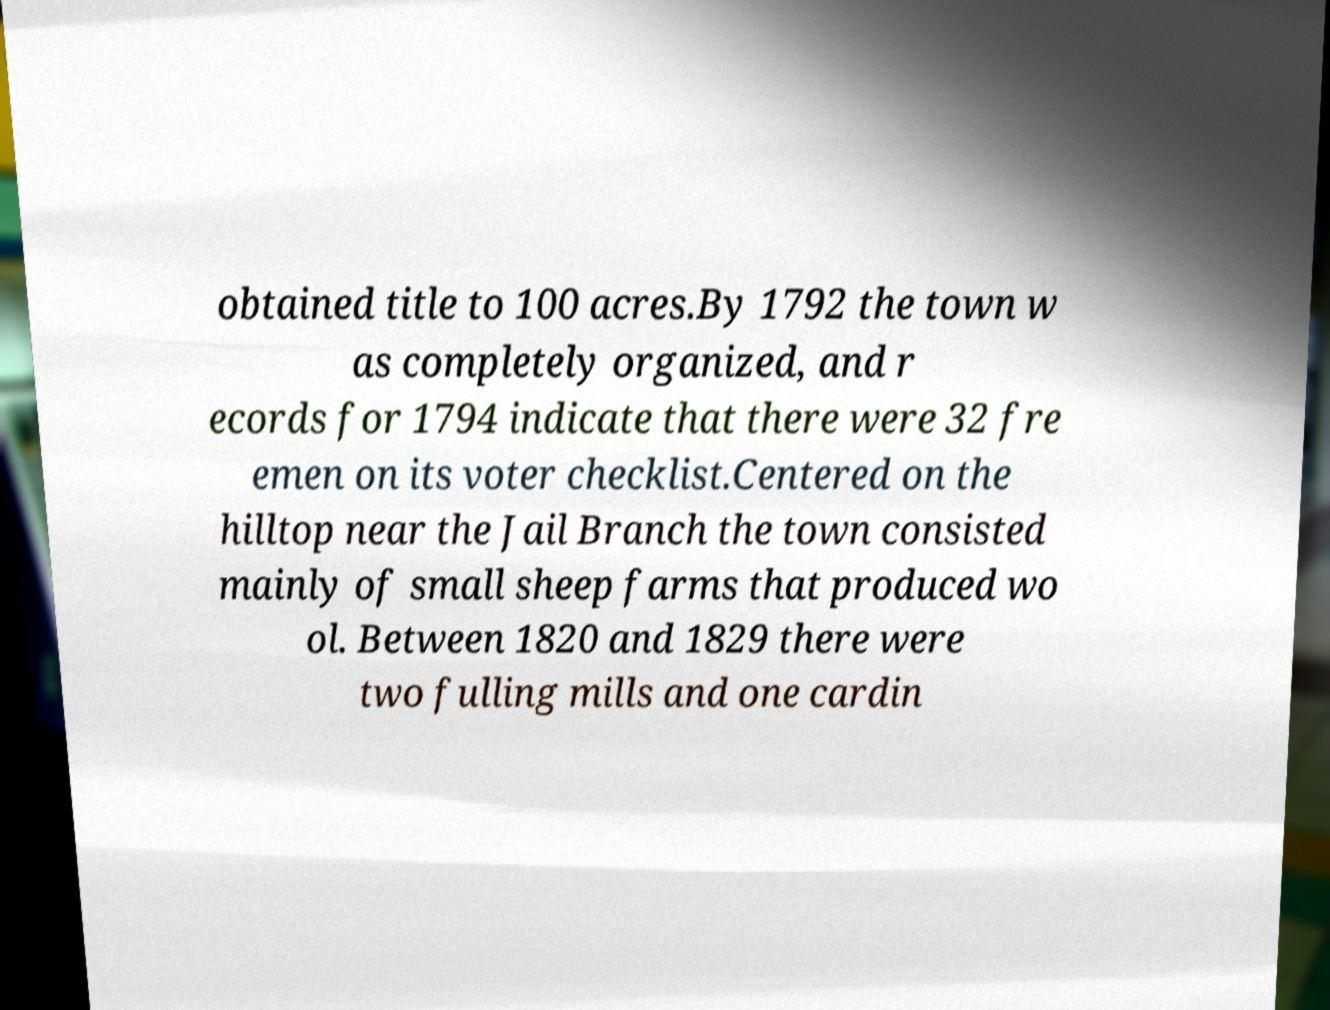Can you read and provide the text displayed in the image?This photo seems to have some interesting text. Can you extract and type it out for me? obtained title to 100 acres.By 1792 the town w as completely organized, and r ecords for 1794 indicate that there were 32 fre emen on its voter checklist.Centered on the hilltop near the Jail Branch the town consisted mainly of small sheep farms that produced wo ol. Between 1820 and 1829 there were two fulling mills and one cardin 